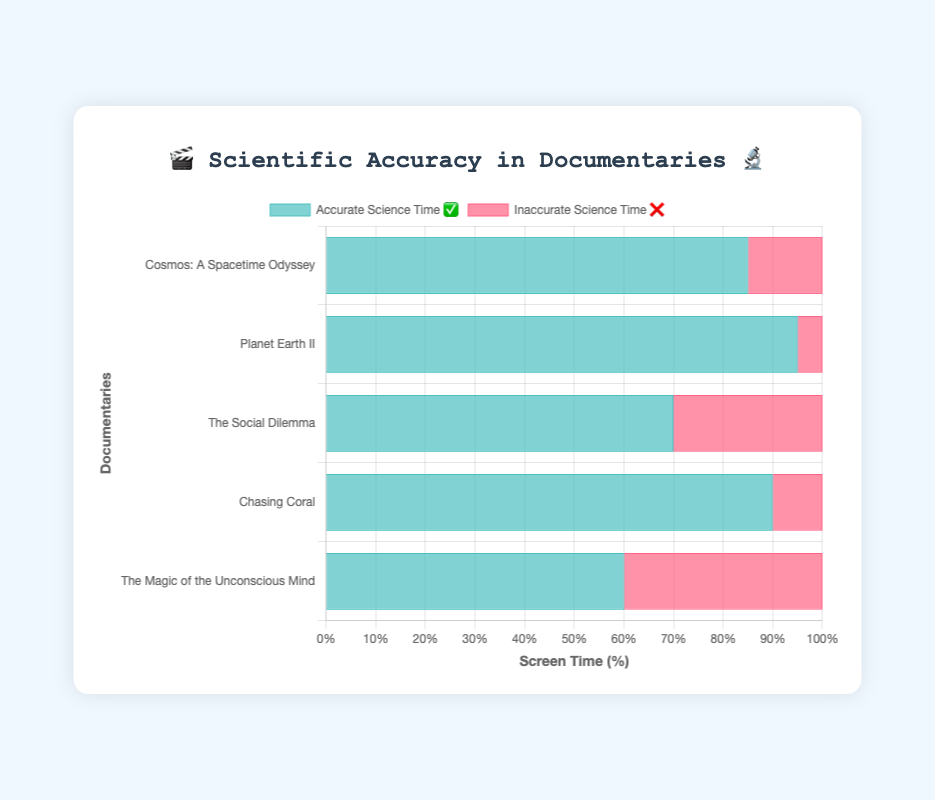What is the title of the figure? The title of the figure is displayed at the center top in a larger font size. It reads "🎬 Scientific Accuracy in Documentaries 🔬".
Answer: 🎬 Scientific Accuracy in Documentaries 🔬 Which documentary has the most accurate science time? By observing the bars representing accurate science time (colored in a greenish hue), "Planet Earth II" has the highest value at 95%.
Answer: Planet Earth II How many documentaries have more than 80% accurate science content? Analyzing the bars for accurate science time, "Cosmos: A Spacetime Odyssey," "Planet Earth II," and "Chasing Coral" all have over 80%. That totals to 3 documentaries.
Answer: 3 What is the combined screen time of accurate science content for "Cosmos: A Spacetime Odyssey" and "Chasing Coral"? Add the accurate science time for "Cosmos: A Spacetime Odyssey" (85%) and "Chasing Coral" (90%) to get the total. 85% + 90% = 175%.
Answer: 175% Which documentary has the greatest difference in screen time between accurate and inaccurate science content? Compare the differences between the accurate and inaccurate science values. "The Magic of the Unconscious Mind" has the greatest difference with 60% accurate and 40% inaccurate, totaling a 20% difference.
Answer: The Magic of the Unconscious Mind What is the average accurate science time across all documentaries? Sum the accurate science times (85 + 95 + 70 + 90 + 60) = 400%. Divide by the number of documentaries (400% / 5 = 80%).
Answer: 80% Is there any documentary where the inaccurate science time exceeds the accurate science time? Comparing the lengths of the bars, in no documentary does the inaccurate science time bar exceed the accurate science time bar.
Answer: No Which documentary has the lowest inaccurate science time? By looking at the bars representing inaccurate science time (colored in a reddish hue), "Planet Earth II" has the lowest at 5%.
Answer: Planet Earth II What is the total screen time percentage for "The Social Dilemma"? Sum the accurate and inaccurate science times for "The Social Dilemma" (70% + 30% = 100%).
Answer: 100% How is the data visualized in the chart? The chart uses horizontal stacked bars to visualize the time distribution of accurate and inaccurate science content across documentaries. Green bars represent accurate content, while red bars represent inaccurate content.
Answer: Horizontal stacked bars 